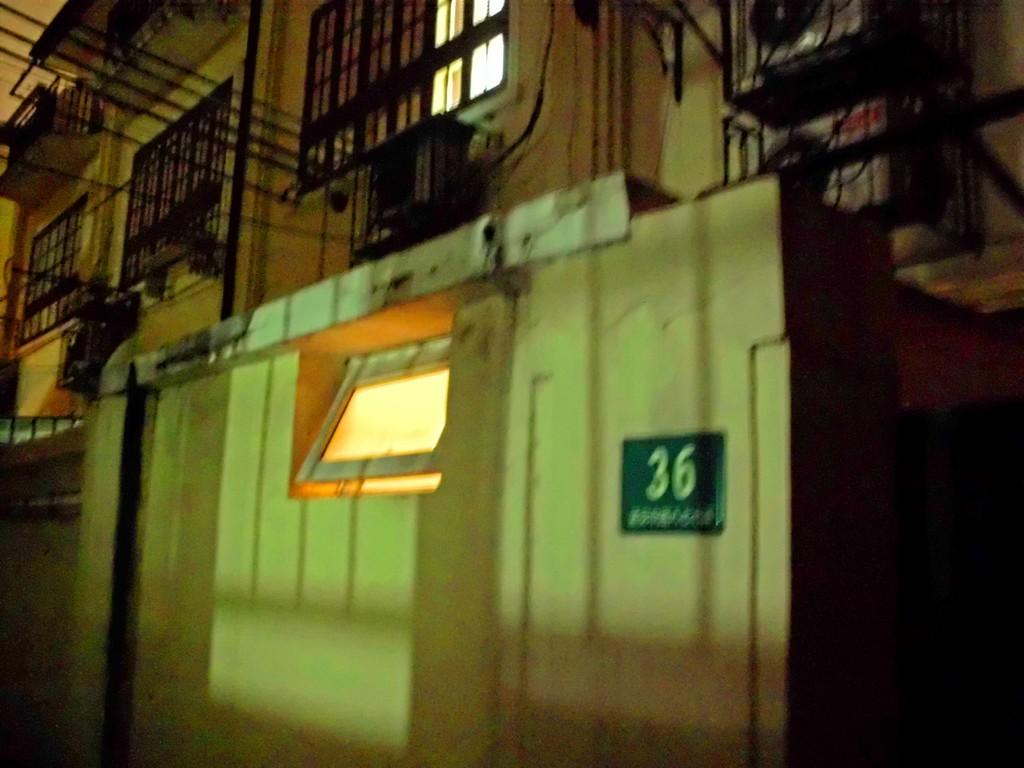What type of structure is visible in the image? There is a building in the image. Can you describe a specific part of the building? There is a small room in the image. What feature allows light and air into the building? There are windows in the image. What type of barrier is present in the image? There are mesh gates in the image. What type of electrical infrastructure is visible in the image? There are wires in the image. What type of cooling system is present in the image? There are air conditioners in the image. What type of signage is present in the image? There is a small board on the wall in the image. Can you describe any other objects visible in the image? There are other objects in the image, but their specific details are not mentioned in the provided facts. What type of shade is provided by the store in the image? There is no store present in the image, and therefore no shade can be provided by a store. 